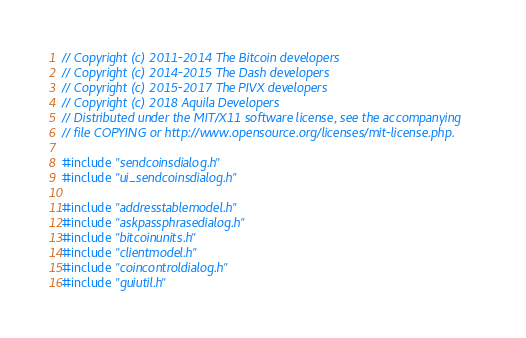<code> <loc_0><loc_0><loc_500><loc_500><_C++_>// Copyright (c) 2011-2014 The Bitcoin developers
// Copyright (c) 2014-2015 The Dash developers
// Copyright (c) 2015-2017 The PIVX developers
// Copyright (c) 2018 Aquila Developers
// Distributed under the MIT/X11 software license, see the accompanying
// file COPYING or http://www.opensource.org/licenses/mit-license.php.

#include "sendcoinsdialog.h"
#include "ui_sendcoinsdialog.h"

#include "addresstablemodel.h"
#include "askpassphrasedialog.h"
#include "bitcoinunits.h"
#include "clientmodel.h"
#include "coincontroldialog.h"
#include "guiutil.h"</code> 